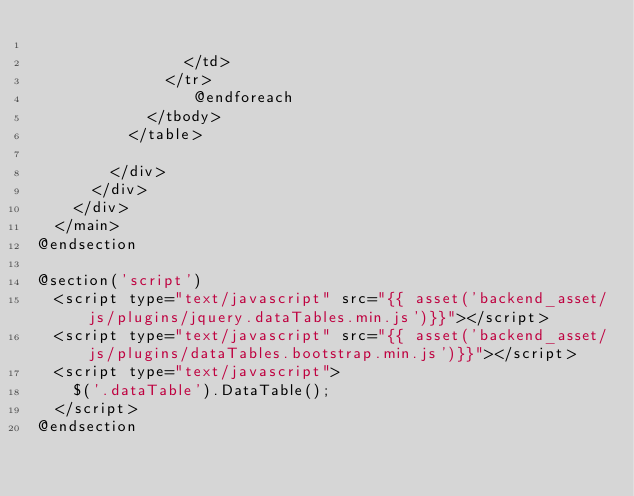<code> <loc_0><loc_0><loc_500><loc_500><_PHP_>
                </td>
              </tr>
                 @endforeach
            </tbody>
          </table>

        </div>
      </div>
    </div>
  </main>
@endsection

@section('script')
  <script type="text/javascript" src="{{ asset('backend_asset/js/plugins/jquery.dataTables.min.js')}}"></script>
  <script type="text/javascript" src="{{ asset('backend_asset/js/plugins/dataTables.bootstrap.min.js')}}"></script>
  <script type="text/javascript">
    $('.dataTable').DataTable();
  </script>
@endsection
</code> 